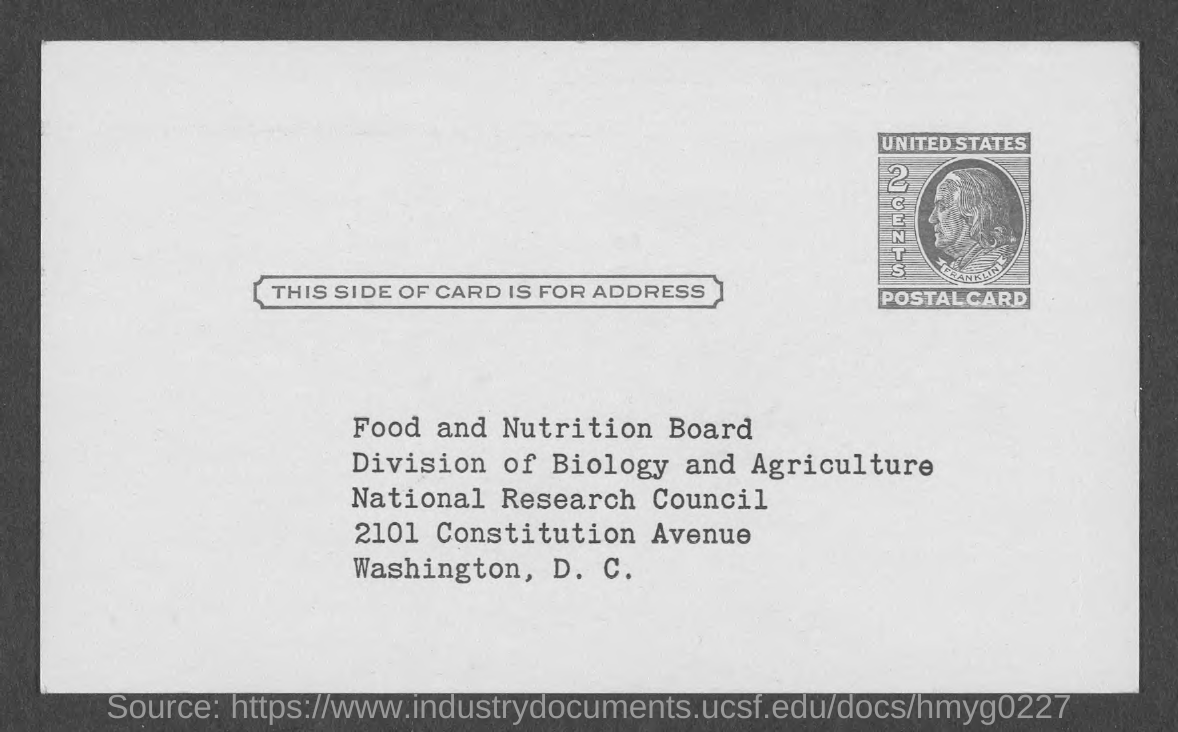Identify some key points in this picture. The postcard should be delivered to the address of Washington, D.C. The value of the postal card is two cents. The postal card belongs to the United States. 